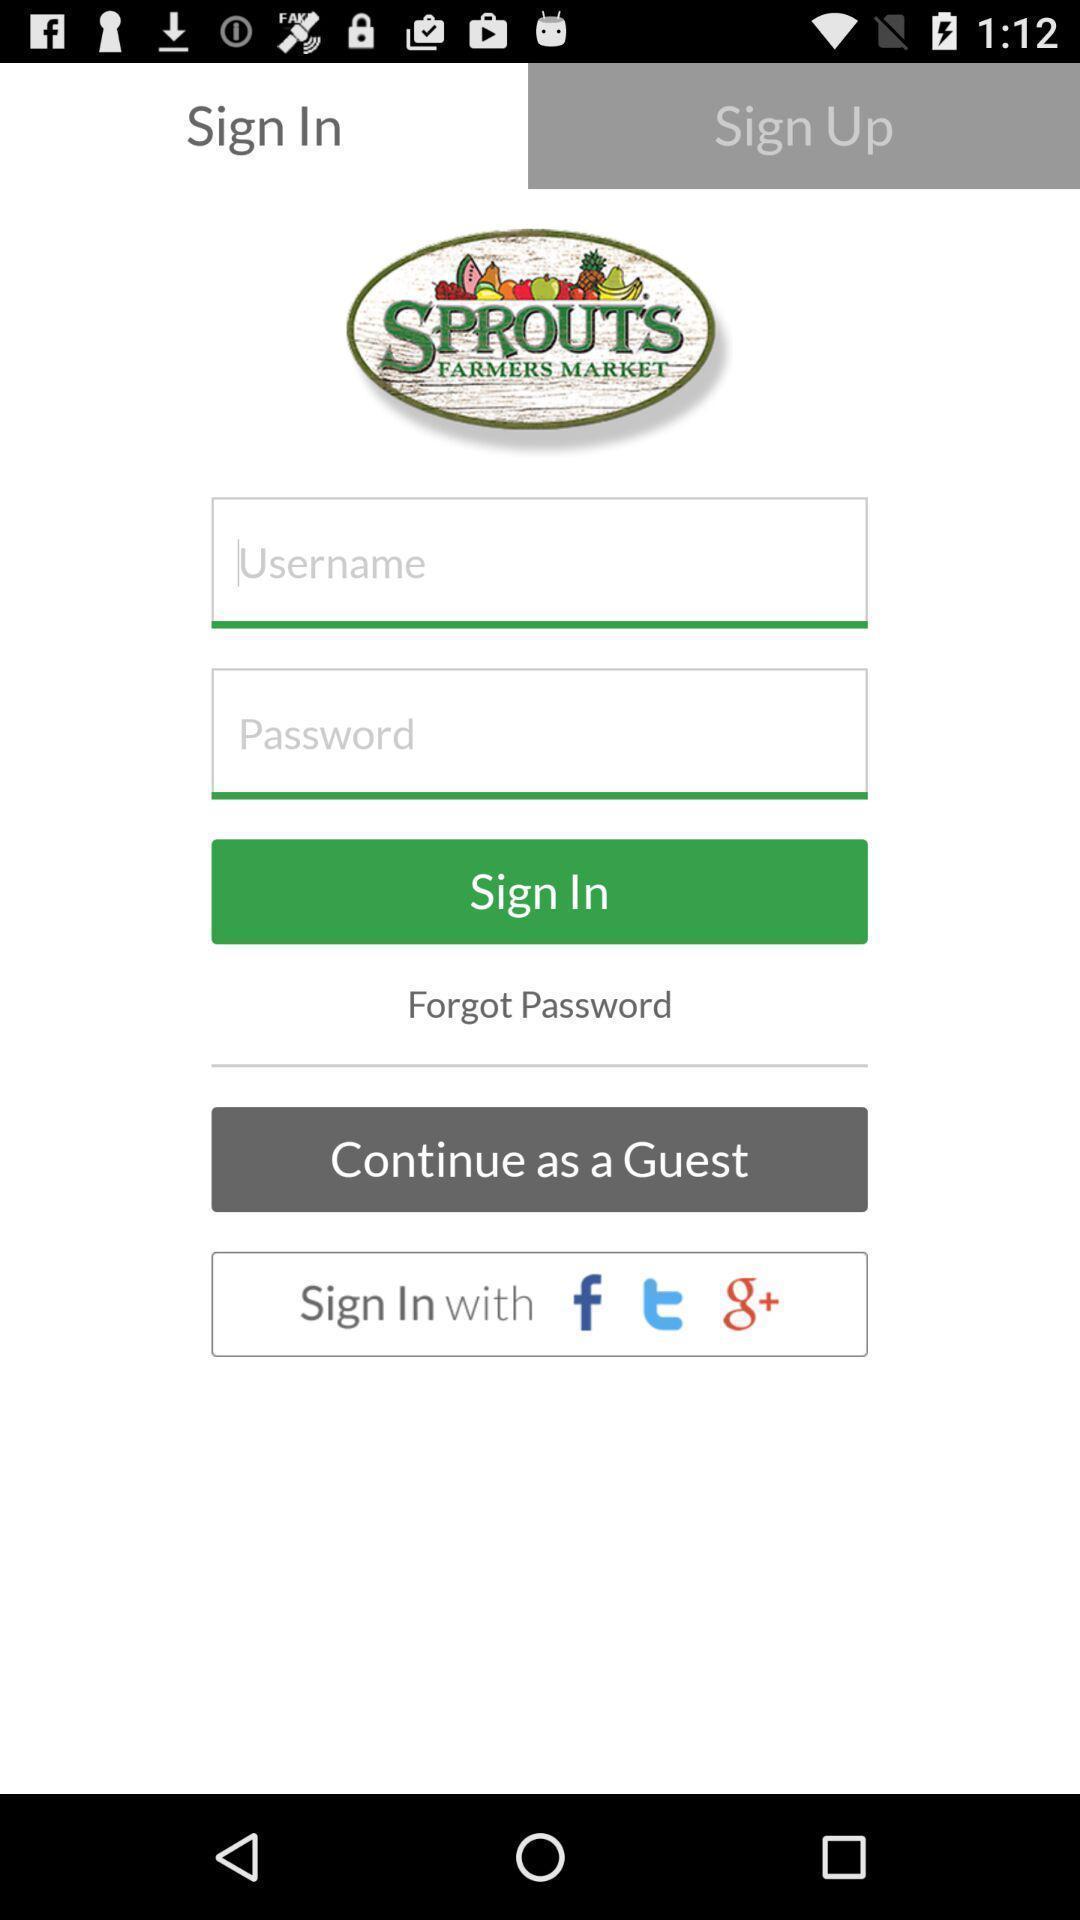Tell me about the visual elements in this screen capture. Sign page. 